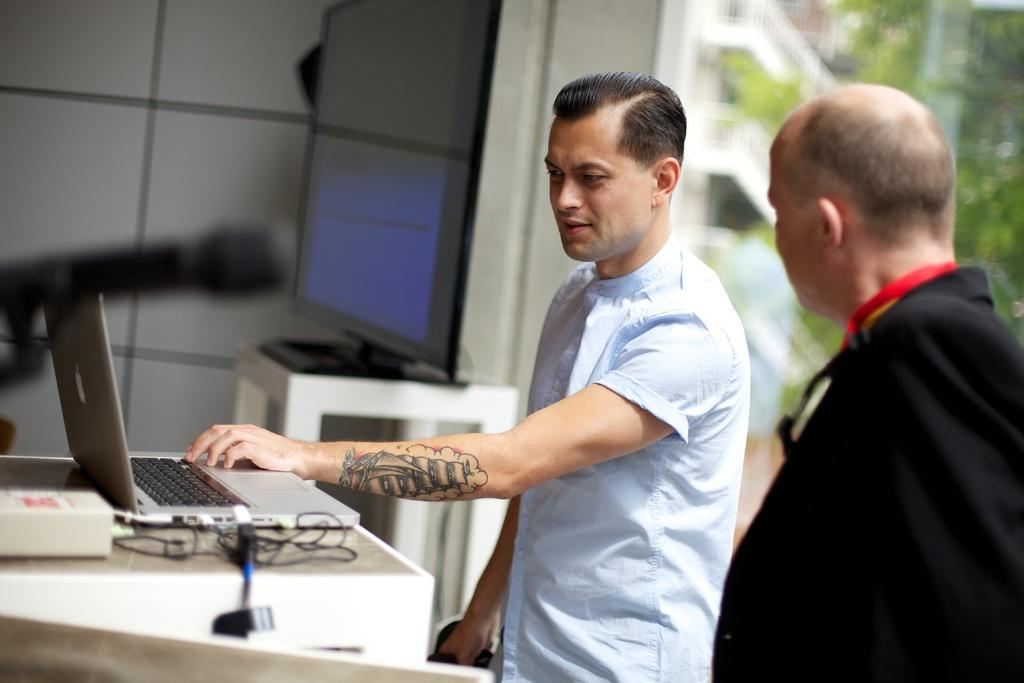What is located on the left side of the image? There is a table on the left side of the image. What is placed on the table? A laptop is present on the table. What else can be seen on the table? There are wires on the table. Who is visible on the right side of the image? There are two men standing on the right side of the image. What can be seen in the background of the image? There is a wall and trees in the background of the image. What type of boat can be seen in the image? There is no boat present in the image. How do the two men express their dislike for each other in the image? The image does not show any indication of the men expressing hate or dislike for each other. 